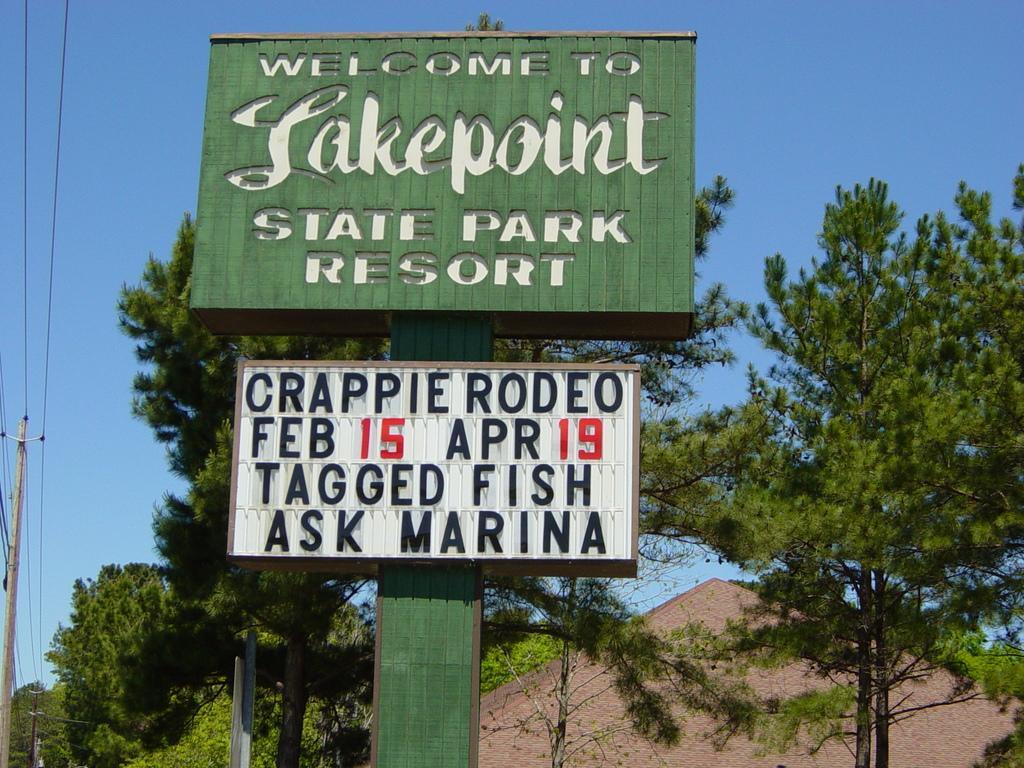Can you describe this image briefly? In this picture we can see boards, poles, wires, trees, and roof. In the background there is sky. 